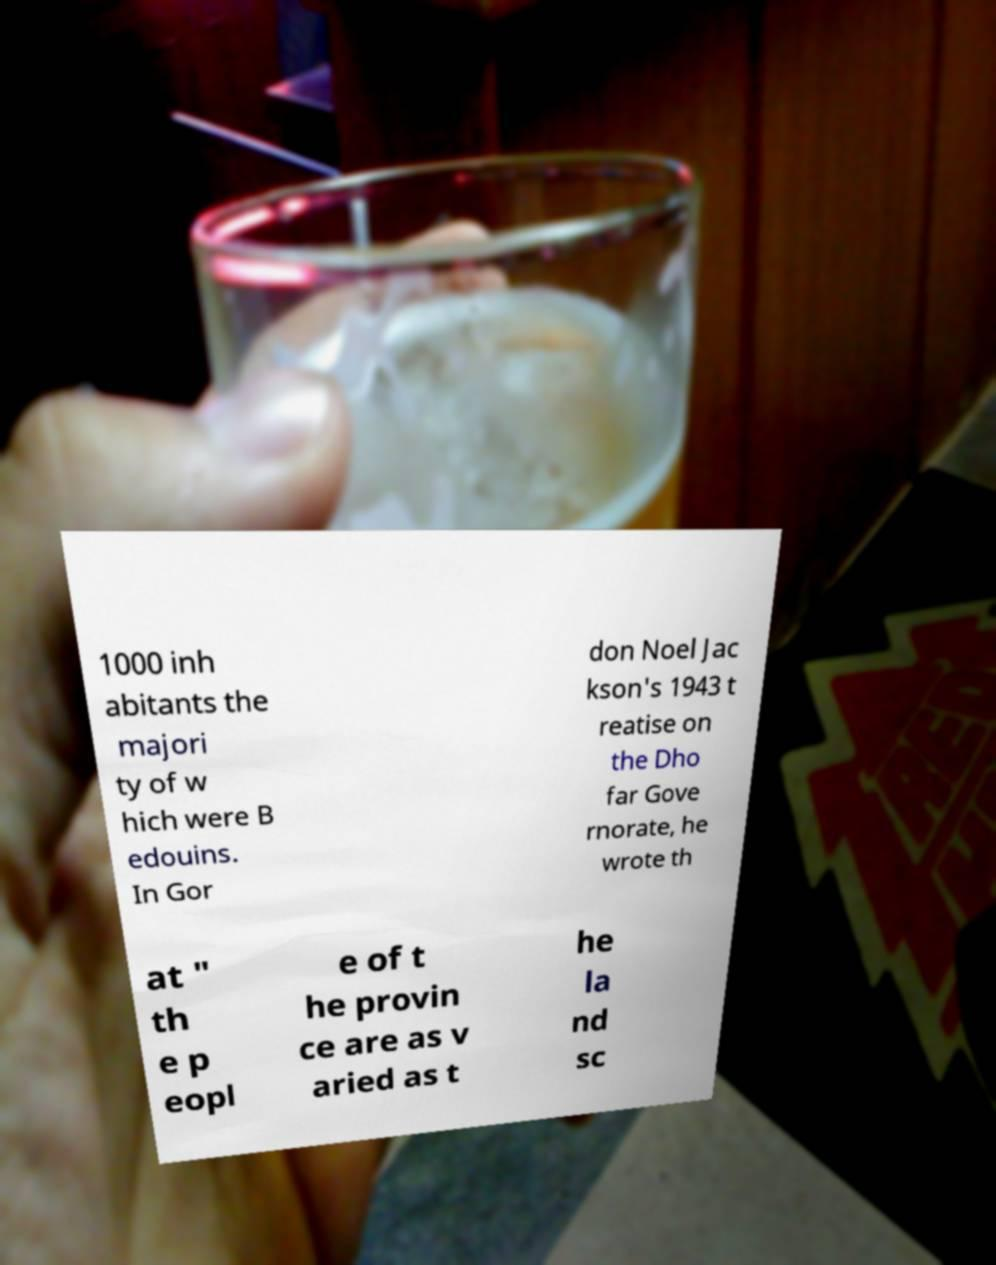Could you assist in decoding the text presented in this image and type it out clearly? 1000 inh abitants the majori ty of w hich were B edouins. In Gor don Noel Jac kson's 1943 t reatise on the Dho far Gove rnorate, he wrote th at " th e p eopl e of t he provin ce are as v aried as t he la nd sc 